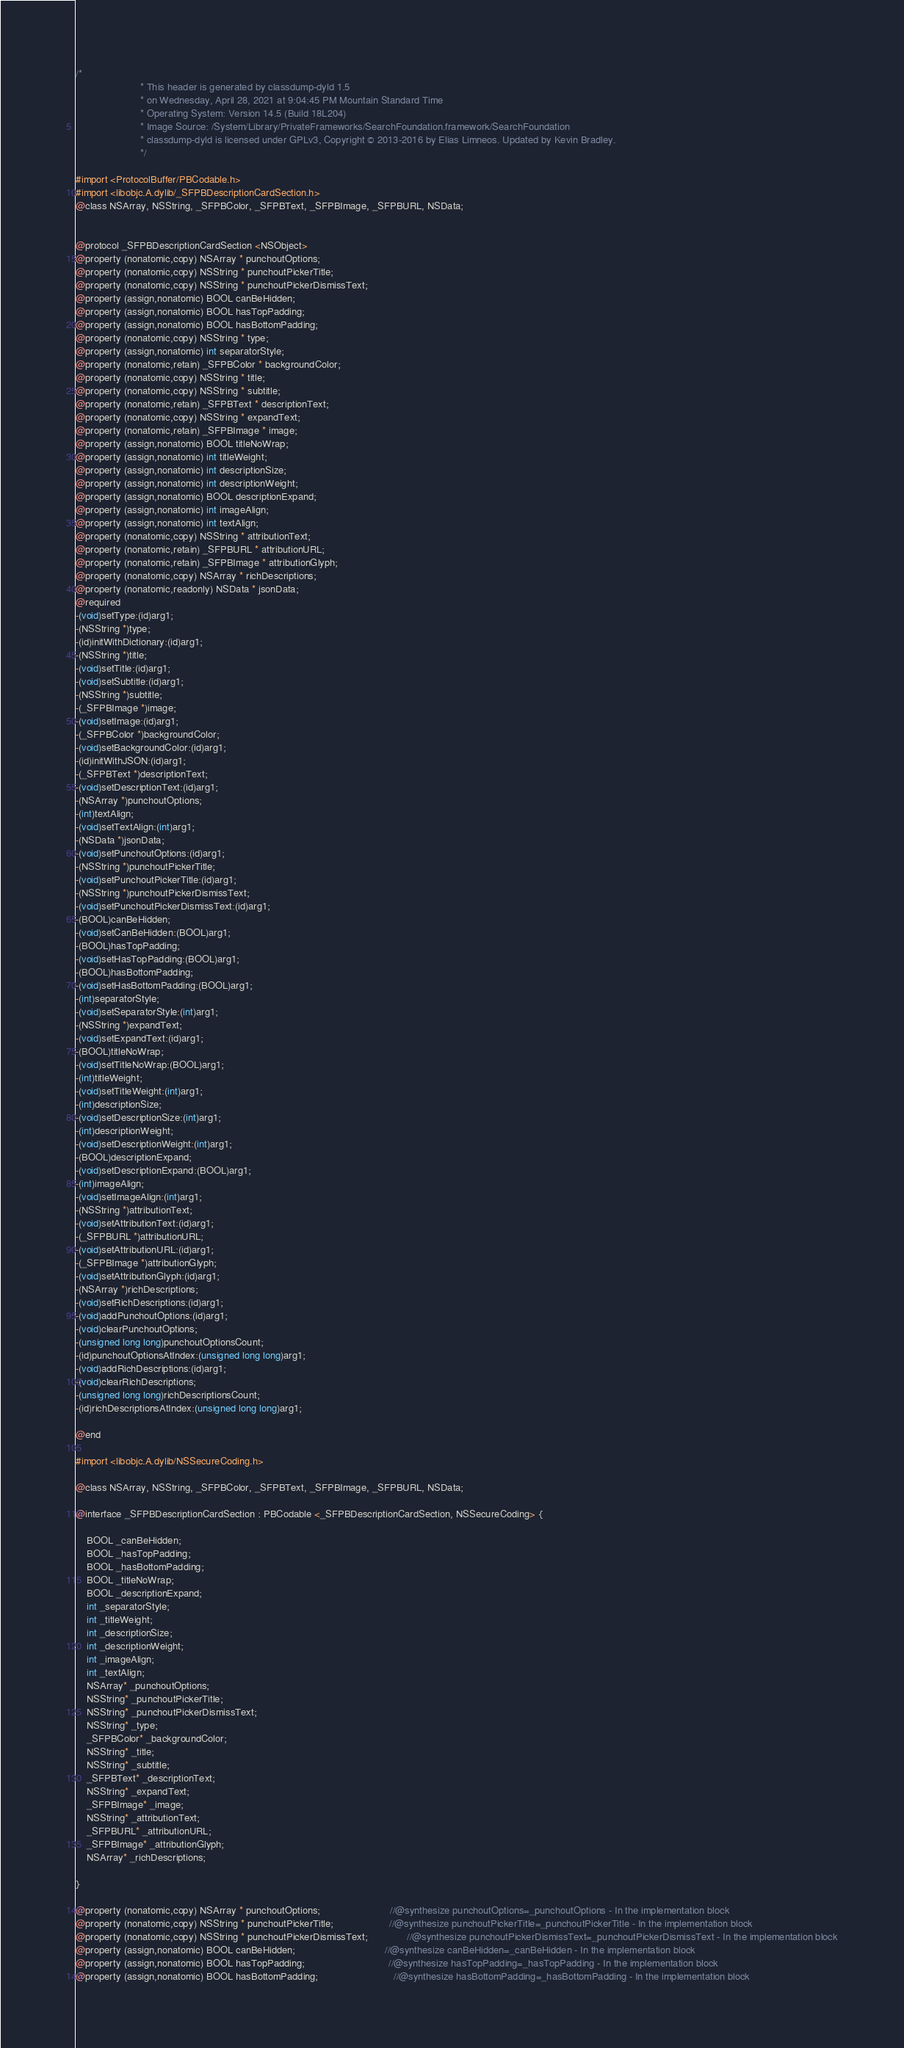<code> <loc_0><loc_0><loc_500><loc_500><_C_>/*
                       * This header is generated by classdump-dyld 1.5
                       * on Wednesday, April 28, 2021 at 9:04:45 PM Mountain Standard Time
                       * Operating System: Version 14.5 (Build 18L204)
                       * Image Source: /System/Library/PrivateFrameworks/SearchFoundation.framework/SearchFoundation
                       * classdump-dyld is licensed under GPLv3, Copyright © 2013-2016 by Elias Limneos. Updated by Kevin Bradley.
                       */

#import <ProtocolBuffer/PBCodable.h>
#import <libobjc.A.dylib/_SFPBDescriptionCardSection.h>
@class NSArray, NSString, _SFPBColor, _SFPBText, _SFPBImage, _SFPBURL, NSData;


@protocol _SFPBDescriptionCardSection <NSObject>
@property (nonatomic,copy) NSArray * punchoutOptions; 
@property (nonatomic,copy) NSString * punchoutPickerTitle; 
@property (nonatomic,copy) NSString * punchoutPickerDismissText; 
@property (assign,nonatomic) BOOL canBeHidden; 
@property (assign,nonatomic) BOOL hasTopPadding; 
@property (assign,nonatomic) BOOL hasBottomPadding; 
@property (nonatomic,copy) NSString * type; 
@property (assign,nonatomic) int separatorStyle; 
@property (nonatomic,retain) _SFPBColor * backgroundColor; 
@property (nonatomic,copy) NSString * title; 
@property (nonatomic,copy) NSString * subtitle; 
@property (nonatomic,retain) _SFPBText * descriptionText; 
@property (nonatomic,copy) NSString * expandText; 
@property (nonatomic,retain) _SFPBImage * image; 
@property (assign,nonatomic) BOOL titleNoWrap; 
@property (assign,nonatomic) int titleWeight; 
@property (assign,nonatomic) int descriptionSize; 
@property (assign,nonatomic) int descriptionWeight; 
@property (assign,nonatomic) BOOL descriptionExpand; 
@property (assign,nonatomic) int imageAlign; 
@property (assign,nonatomic) int textAlign; 
@property (nonatomic,copy) NSString * attributionText; 
@property (nonatomic,retain) _SFPBURL * attributionURL; 
@property (nonatomic,retain) _SFPBImage * attributionGlyph; 
@property (nonatomic,copy) NSArray * richDescriptions; 
@property (nonatomic,readonly) NSData * jsonData; 
@required
-(void)setType:(id)arg1;
-(NSString *)type;
-(id)initWithDictionary:(id)arg1;
-(NSString *)title;
-(void)setTitle:(id)arg1;
-(void)setSubtitle:(id)arg1;
-(NSString *)subtitle;
-(_SFPBImage *)image;
-(void)setImage:(id)arg1;
-(_SFPBColor *)backgroundColor;
-(void)setBackgroundColor:(id)arg1;
-(id)initWithJSON:(id)arg1;
-(_SFPBText *)descriptionText;
-(void)setDescriptionText:(id)arg1;
-(NSArray *)punchoutOptions;
-(int)textAlign;
-(void)setTextAlign:(int)arg1;
-(NSData *)jsonData;
-(void)setPunchoutOptions:(id)arg1;
-(NSString *)punchoutPickerTitle;
-(void)setPunchoutPickerTitle:(id)arg1;
-(NSString *)punchoutPickerDismissText;
-(void)setPunchoutPickerDismissText:(id)arg1;
-(BOOL)canBeHidden;
-(void)setCanBeHidden:(BOOL)arg1;
-(BOOL)hasTopPadding;
-(void)setHasTopPadding:(BOOL)arg1;
-(BOOL)hasBottomPadding;
-(void)setHasBottomPadding:(BOOL)arg1;
-(int)separatorStyle;
-(void)setSeparatorStyle:(int)arg1;
-(NSString *)expandText;
-(void)setExpandText:(id)arg1;
-(BOOL)titleNoWrap;
-(void)setTitleNoWrap:(BOOL)arg1;
-(int)titleWeight;
-(void)setTitleWeight:(int)arg1;
-(int)descriptionSize;
-(void)setDescriptionSize:(int)arg1;
-(int)descriptionWeight;
-(void)setDescriptionWeight:(int)arg1;
-(BOOL)descriptionExpand;
-(void)setDescriptionExpand:(BOOL)arg1;
-(int)imageAlign;
-(void)setImageAlign:(int)arg1;
-(NSString *)attributionText;
-(void)setAttributionText:(id)arg1;
-(_SFPBURL *)attributionURL;
-(void)setAttributionURL:(id)arg1;
-(_SFPBImage *)attributionGlyph;
-(void)setAttributionGlyph:(id)arg1;
-(NSArray *)richDescriptions;
-(void)setRichDescriptions:(id)arg1;
-(void)addPunchoutOptions:(id)arg1;
-(void)clearPunchoutOptions;
-(unsigned long long)punchoutOptionsCount;
-(id)punchoutOptionsAtIndex:(unsigned long long)arg1;
-(void)addRichDescriptions:(id)arg1;
-(void)clearRichDescriptions;
-(unsigned long long)richDescriptionsCount;
-(id)richDescriptionsAtIndex:(unsigned long long)arg1;

@end

#import <libobjc.A.dylib/NSSecureCoding.h>

@class NSArray, NSString, _SFPBColor, _SFPBText, _SFPBImage, _SFPBURL, NSData;

@interface _SFPBDescriptionCardSection : PBCodable <_SFPBDescriptionCardSection, NSSecureCoding> {

	BOOL _canBeHidden;
	BOOL _hasTopPadding;
	BOOL _hasBottomPadding;
	BOOL _titleNoWrap;
	BOOL _descriptionExpand;
	int _separatorStyle;
	int _titleWeight;
	int _descriptionSize;
	int _descriptionWeight;
	int _imageAlign;
	int _textAlign;
	NSArray* _punchoutOptions;
	NSString* _punchoutPickerTitle;
	NSString* _punchoutPickerDismissText;
	NSString* _type;
	_SFPBColor* _backgroundColor;
	NSString* _title;
	NSString* _subtitle;
	_SFPBText* _descriptionText;
	NSString* _expandText;
	_SFPBImage* _image;
	NSString* _attributionText;
	_SFPBURL* _attributionURL;
	_SFPBImage* _attributionGlyph;
	NSArray* _richDescriptions;

}

@property (nonatomic,copy) NSArray * punchoutOptions;                         //@synthesize punchoutOptions=_punchoutOptions - In the implementation block
@property (nonatomic,copy) NSString * punchoutPickerTitle;                    //@synthesize punchoutPickerTitle=_punchoutPickerTitle - In the implementation block
@property (nonatomic,copy) NSString * punchoutPickerDismissText;              //@synthesize punchoutPickerDismissText=_punchoutPickerDismissText - In the implementation block
@property (assign,nonatomic) BOOL canBeHidden;                                //@synthesize canBeHidden=_canBeHidden - In the implementation block
@property (assign,nonatomic) BOOL hasTopPadding;                              //@synthesize hasTopPadding=_hasTopPadding - In the implementation block
@property (assign,nonatomic) BOOL hasBottomPadding;                           //@synthesize hasBottomPadding=_hasBottomPadding - In the implementation block</code> 